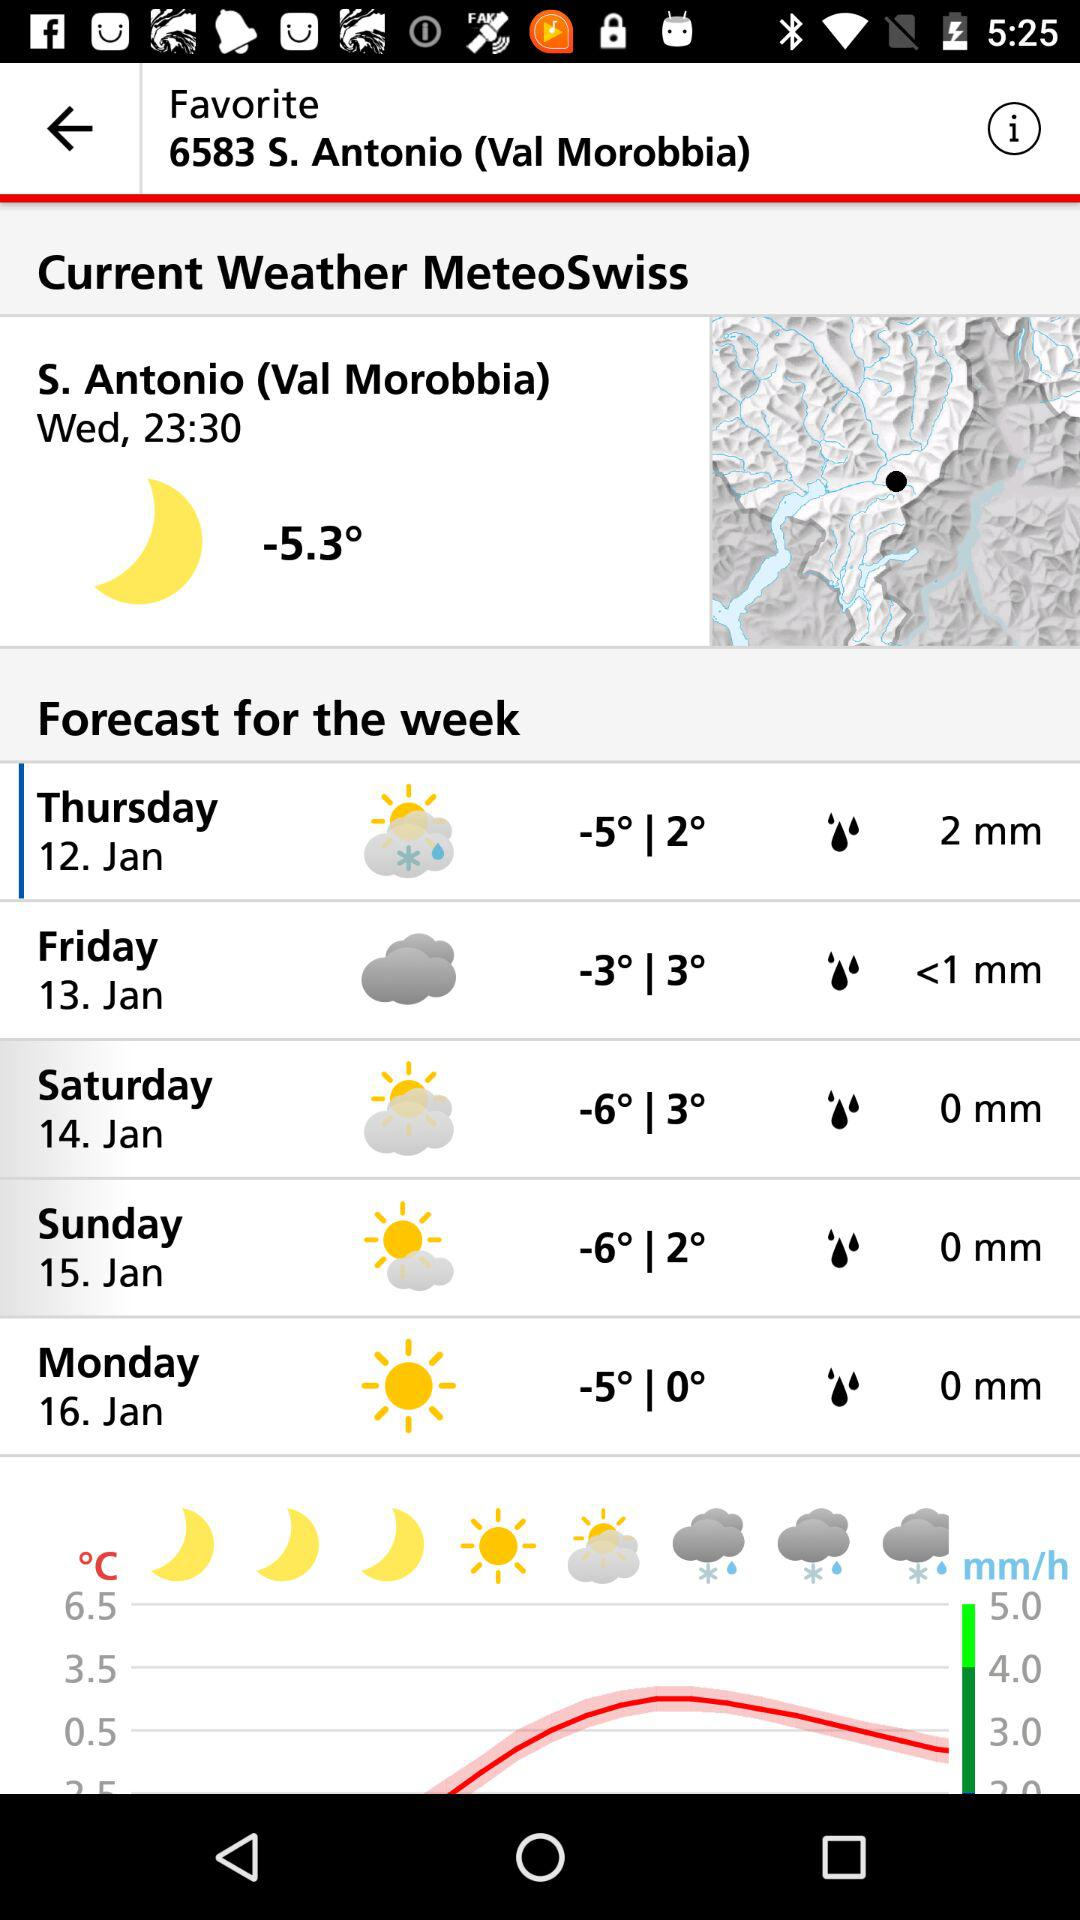What is the name of the country?
When the provided information is insufficient, respond with <no answer>. <no answer> 